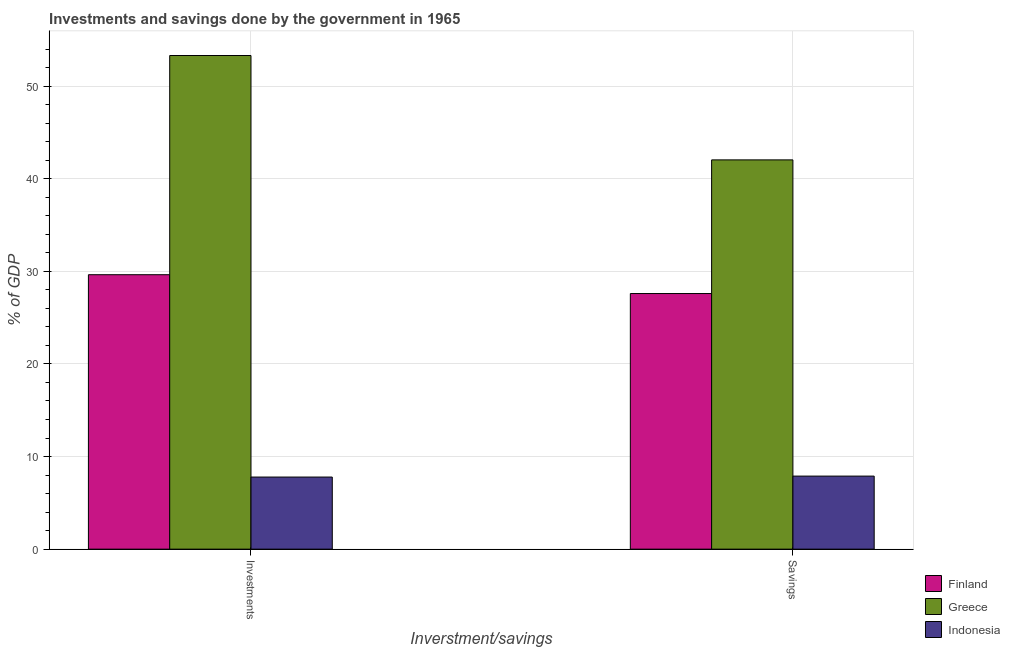How many bars are there on the 2nd tick from the left?
Your answer should be compact. 3. What is the label of the 2nd group of bars from the left?
Your answer should be compact. Savings. What is the investments of government in Indonesia?
Keep it short and to the point. 7.79. Across all countries, what is the maximum savings of government?
Offer a terse response. 42.04. Across all countries, what is the minimum savings of government?
Offer a terse response. 7.89. In which country was the savings of government minimum?
Give a very brief answer. Indonesia. What is the total savings of government in the graph?
Offer a very short reply. 77.53. What is the difference between the savings of government in Indonesia and that in Greece?
Offer a terse response. -34.15. What is the difference between the savings of government in Greece and the investments of government in Finland?
Offer a very short reply. 12.4. What is the average investments of government per country?
Give a very brief answer. 30.25. What is the difference between the savings of government and investments of government in Finland?
Your answer should be very brief. -2.03. What is the ratio of the savings of government in Indonesia to that in Greece?
Give a very brief answer. 0.19. Is the investments of government in Greece less than that in Indonesia?
Your answer should be compact. No. In how many countries, is the savings of government greater than the average savings of government taken over all countries?
Keep it short and to the point. 2. What does the 3rd bar from the left in Savings represents?
Provide a succinct answer. Indonesia. What does the 1st bar from the right in Savings represents?
Your answer should be compact. Indonesia. Are all the bars in the graph horizontal?
Ensure brevity in your answer.  No. How many countries are there in the graph?
Make the answer very short. 3. What is the difference between two consecutive major ticks on the Y-axis?
Provide a short and direct response. 10. Does the graph contain grids?
Your answer should be very brief. Yes. How are the legend labels stacked?
Offer a very short reply. Vertical. What is the title of the graph?
Provide a succinct answer. Investments and savings done by the government in 1965. Does "Vanuatu" appear as one of the legend labels in the graph?
Offer a terse response. No. What is the label or title of the X-axis?
Ensure brevity in your answer.  Inverstment/savings. What is the label or title of the Y-axis?
Provide a succinct answer. % of GDP. What is the % of GDP of Finland in Investments?
Provide a succinct answer. 29.64. What is the % of GDP of Greece in Investments?
Keep it short and to the point. 53.31. What is the % of GDP in Indonesia in Investments?
Make the answer very short. 7.79. What is the % of GDP in Finland in Savings?
Offer a very short reply. 27.61. What is the % of GDP of Greece in Savings?
Your response must be concise. 42.04. What is the % of GDP of Indonesia in Savings?
Provide a short and direct response. 7.89. Across all Inverstment/savings, what is the maximum % of GDP of Finland?
Give a very brief answer. 29.64. Across all Inverstment/savings, what is the maximum % of GDP in Greece?
Provide a short and direct response. 53.31. Across all Inverstment/savings, what is the maximum % of GDP of Indonesia?
Provide a short and direct response. 7.89. Across all Inverstment/savings, what is the minimum % of GDP of Finland?
Offer a very short reply. 27.61. Across all Inverstment/savings, what is the minimum % of GDP of Greece?
Your response must be concise. 42.04. Across all Inverstment/savings, what is the minimum % of GDP of Indonesia?
Offer a terse response. 7.79. What is the total % of GDP of Finland in the graph?
Provide a short and direct response. 57.24. What is the total % of GDP of Greece in the graph?
Provide a succinct answer. 95.35. What is the total % of GDP of Indonesia in the graph?
Provide a succinct answer. 15.68. What is the difference between the % of GDP in Finland in Investments and that in Savings?
Ensure brevity in your answer.  2.03. What is the difference between the % of GDP of Greece in Investments and that in Savings?
Offer a very short reply. 11.27. What is the difference between the % of GDP in Indonesia in Investments and that in Savings?
Offer a very short reply. -0.1. What is the difference between the % of GDP in Finland in Investments and the % of GDP in Greece in Savings?
Your answer should be very brief. -12.4. What is the difference between the % of GDP in Finland in Investments and the % of GDP in Indonesia in Savings?
Keep it short and to the point. 21.75. What is the difference between the % of GDP in Greece in Investments and the % of GDP in Indonesia in Savings?
Provide a succinct answer. 45.42. What is the average % of GDP in Finland per Inverstment/savings?
Your answer should be compact. 28.62. What is the average % of GDP of Greece per Inverstment/savings?
Give a very brief answer. 47.68. What is the average % of GDP in Indonesia per Inverstment/savings?
Ensure brevity in your answer.  7.84. What is the difference between the % of GDP of Finland and % of GDP of Greece in Investments?
Make the answer very short. -23.67. What is the difference between the % of GDP in Finland and % of GDP in Indonesia in Investments?
Provide a succinct answer. 21.85. What is the difference between the % of GDP in Greece and % of GDP in Indonesia in Investments?
Keep it short and to the point. 45.53. What is the difference between the % of GDP in Finland and % of GDP in Greece in Savings?
Your answer should be very brief. -14.43. What is the difference between the % of GDP in Finland and % of GDP in Indonesia in Savings?
Offer a terse response. 19.72. What is the difference between the % of GDP of Greece and % of GDP of Indonesia in Savings?
Your answer should be very brief. 34.15. What is the ratio of the % of GDP in Finland in Investments to that in Savings?
Your response must be concise. 1.07. What is the ratio of the % of GDP of Greece in Investments to that in Savings?
Provide a succinct answer. 1.27. What is the ratio of the % of GDP of Indonesia in Investments to that in Savings?
Your answer should be compact. 0.99. What is the difference between the highest and the second highest % of GDP of Finland?
Your answer should be compact. 2.03. What is the difference between the highest and the second highest % of GDP in Greece?
Your answer should be compact. 11.27. What is the difference between the highest and the second highest % of GDP of Indonesia?
Your answer should be very brief. 0.1. What is the difference between the highest and the lowest % of GDP of Finland?
Offer a very short reply. 2.03. What is the difference between the highest and the lowest % of GDP in Greece?
Keep it short and to the point. 11.27. What is the difference between the highest and the lowest % of GDP of Indonesia?
Provide a short and direct response. 0.1. 